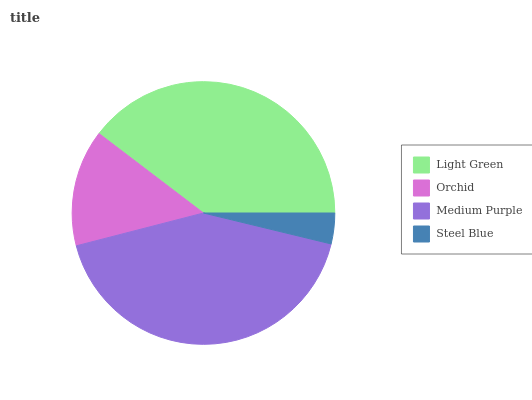Is Steel Blue the minimum?
Answer yes or no. Yes. Is Medium Purple the maximum?
Answer yes or no. Yes. Is Orchid the minimum?
Answer yes or no. No. Is Orchid the maximum?
Answer yes or no. No. Is Light Green greater than Orchid?
Answer yes or no. Yes. Is Orchid less than Light Green?
Answer yes or no. Yes. Is Orchid greater than Light Green?
Answer yes or no. No. Is Light Green less than Orchid?
Answer yes or no. No. Is Light Green the high median?
Answer yes or no. Yes. Is Orchid the low median?
Answer yes or no. Yes. Is Orchid the high median?
Answer yes or no. No. Is Steel Blue the low median?
Answer yes or no. No. 